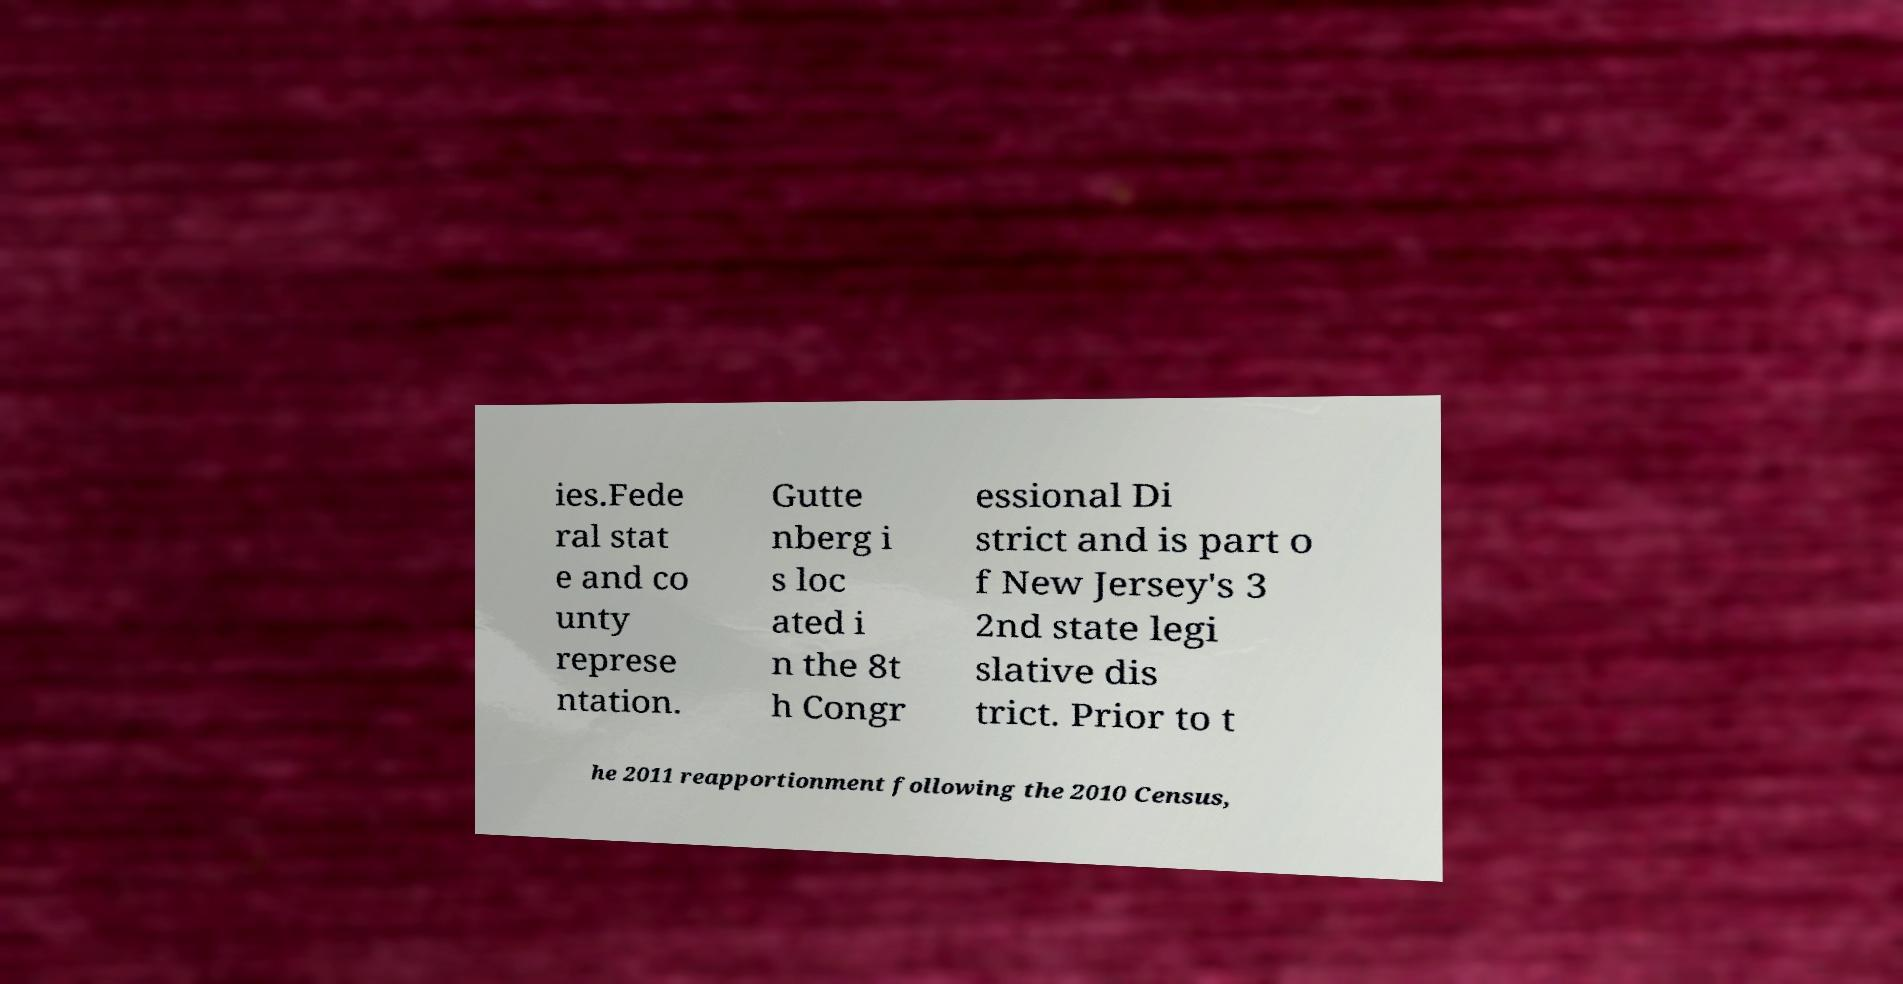Please read and relay the text visible in this image. What does it say? ies.Fede ral stat e and co unty represe ntation. Gutte nberg i s loc ated i n the 8t h Congr essional Di strict and is part o f New Jersey's 3 2nd state legi slative dis trict. Prior to t he 2011 reapportionment following the 2010 Census, 